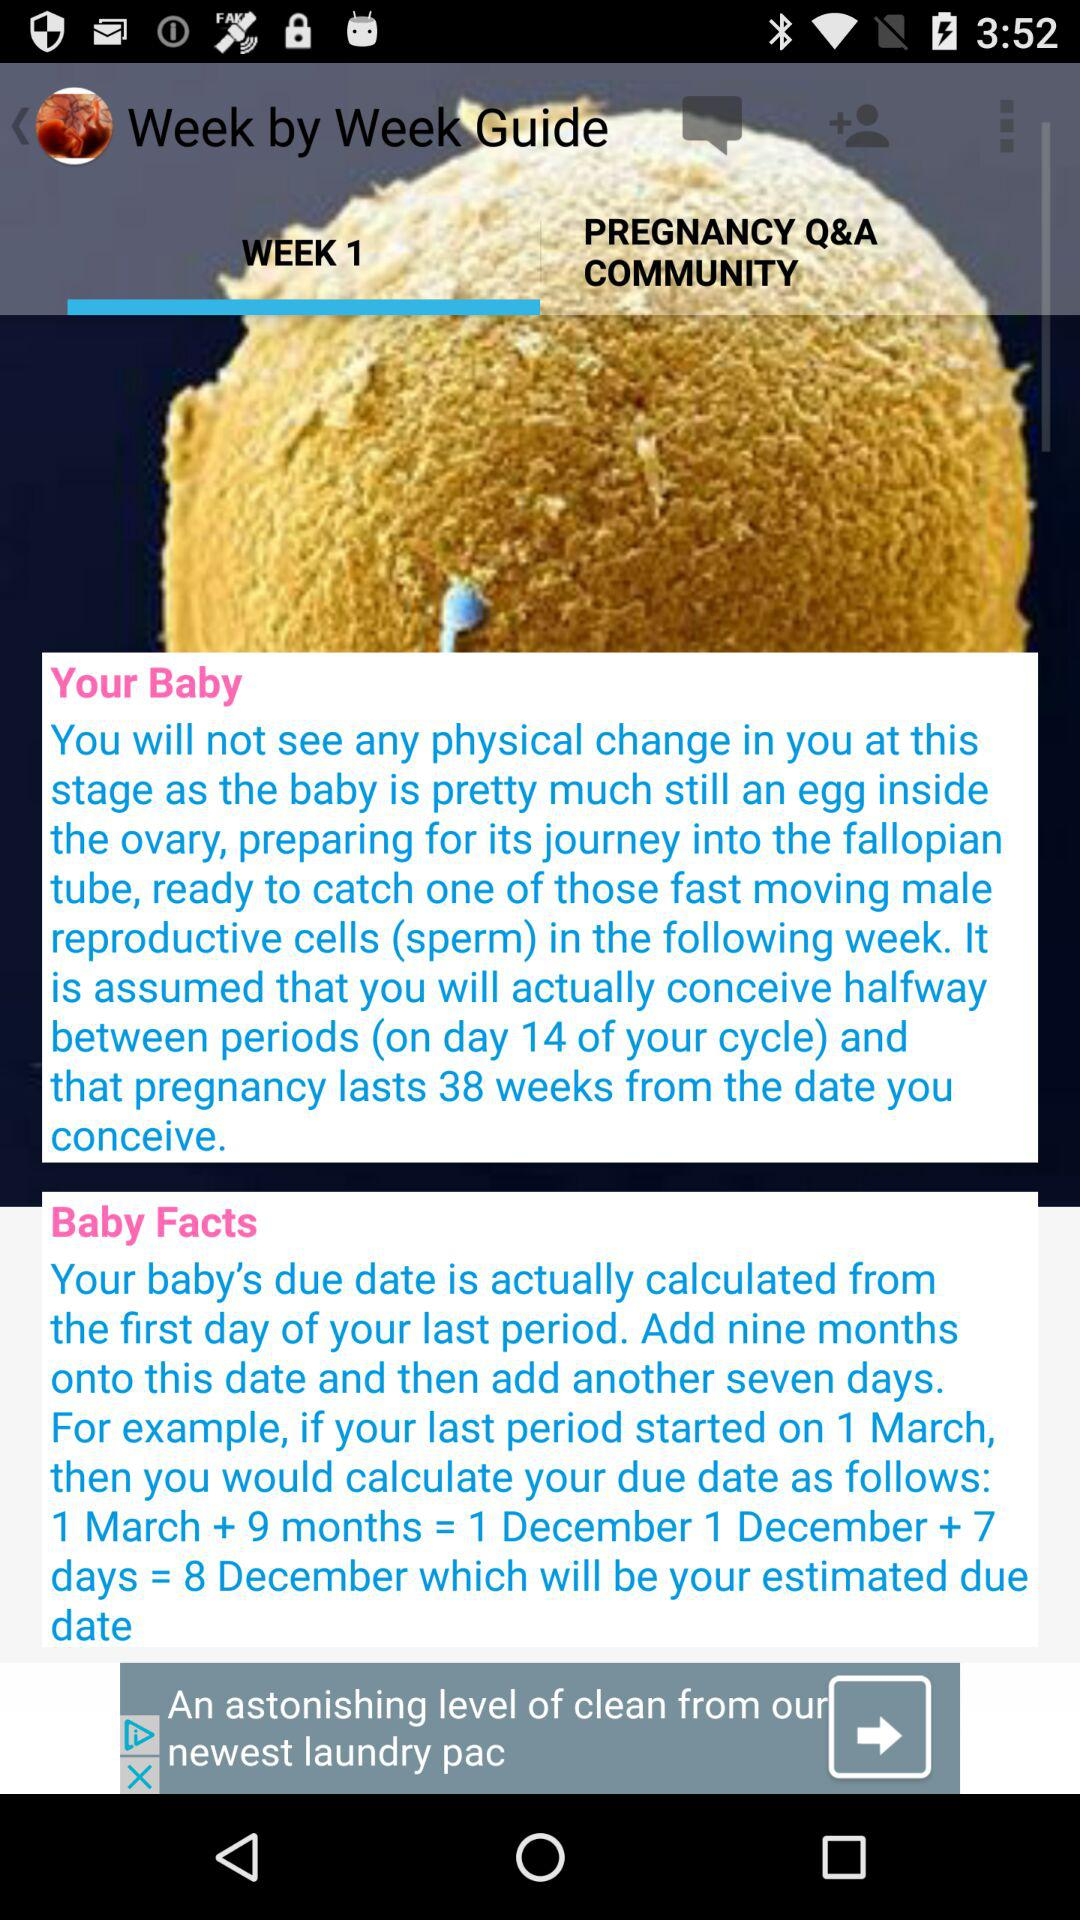How long does pregnancy last? Pregnancy lasts for 38 weeks. 